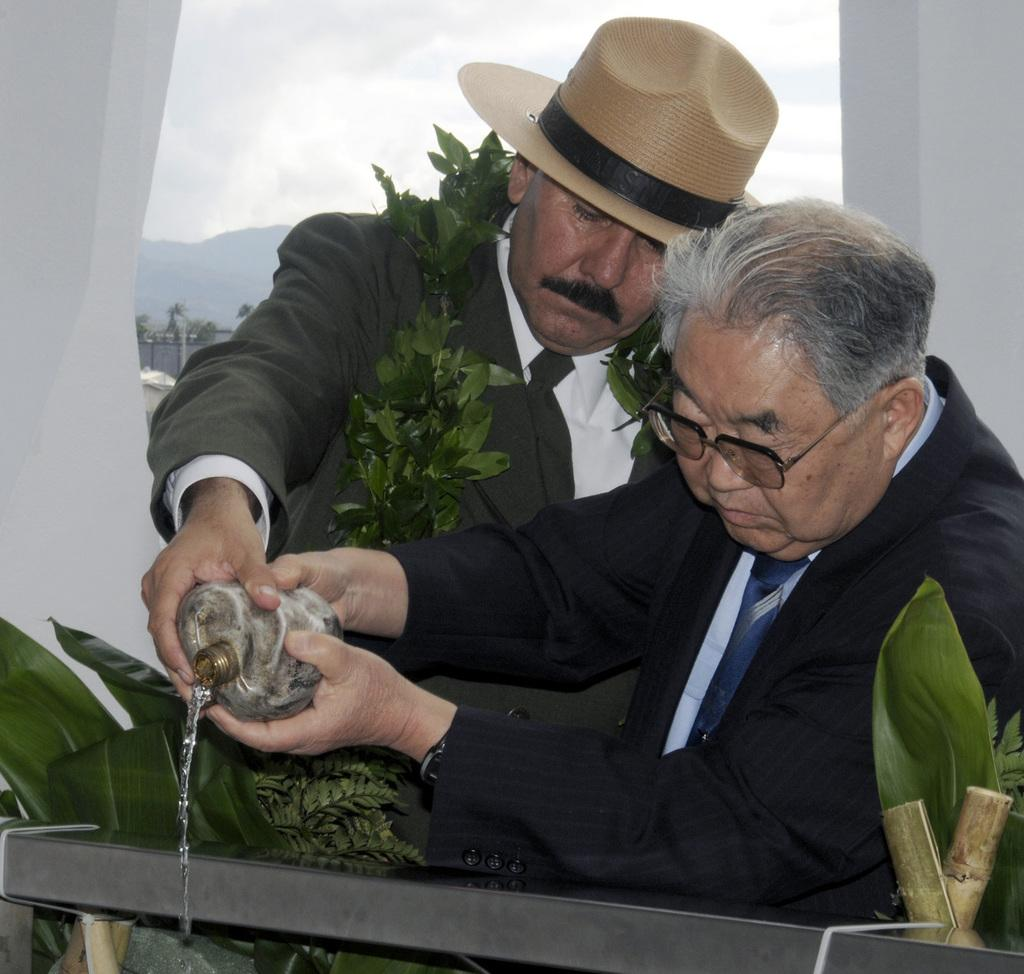What is located at the bottom of the image? There are plants at the bottom of the image. What can be seen in the image besides the plants? There is fencing, two persons standing in the middle of the image, and a wall in the background. What are the two persons holding in the image? The two persons are holding a bottle. What is the background of the image? There is a wall in the background of the image. Can you tell me what type of river is flowing behind the wall in the image? There is no river present in the image; it only features plants, fencing, two persons holding a bottle, and a wall in the background. What type of secretary is assisting the carpenter in the image? There is no carpenter or secretary present in the image. 